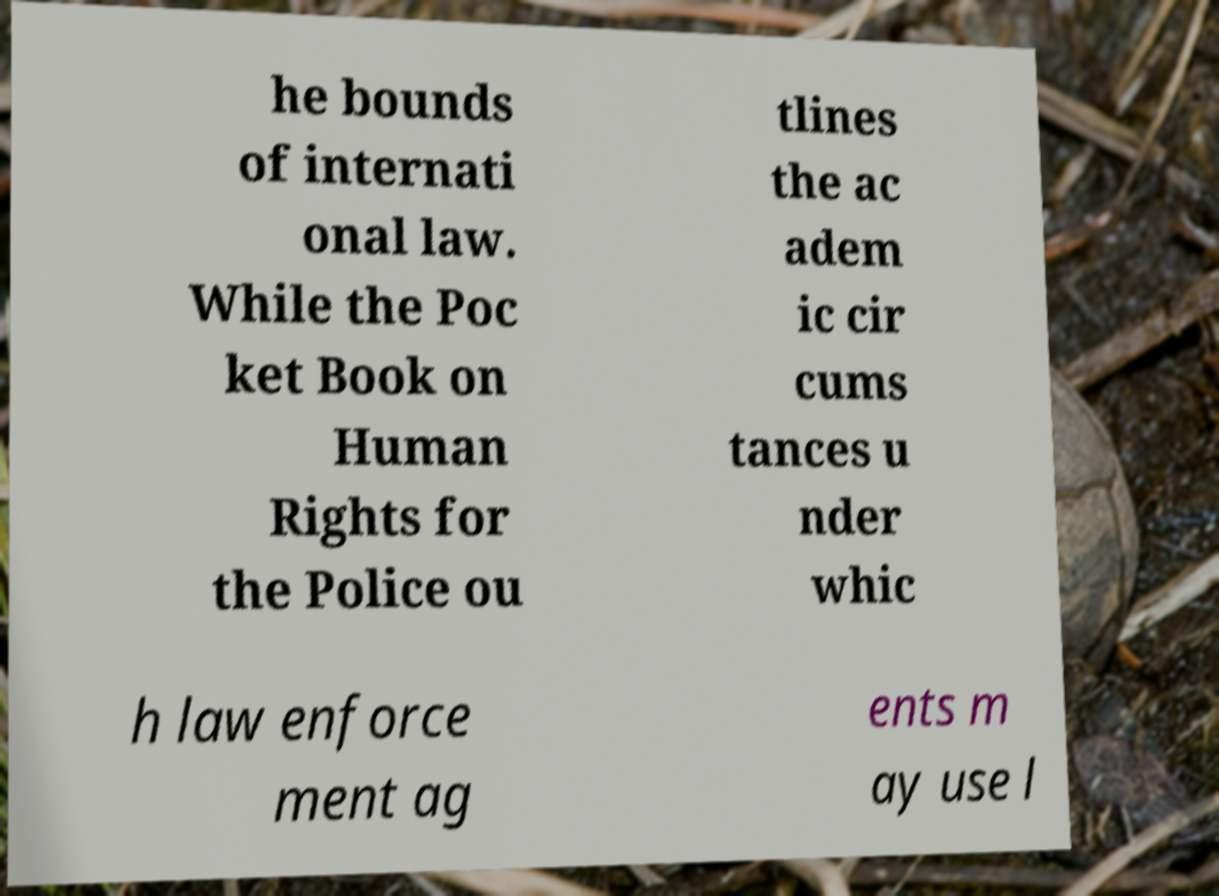Please identify and transcribe the text found in this image. he bounds of internati onal law. While the Poc ket Book on Human Rights for the Police ou tlines the ac adem ic cir cums tances u nder whic h law enforce ment ag ents m ay use l 